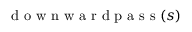<formula> <loc_0><loc_0><loc_500><loc_500>d o w n w a r d p a s s ( s )</formula> 